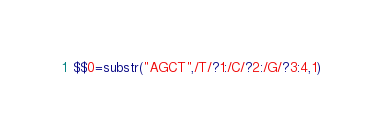Convert code to text. <code><loc_0><loc_0><loc_500><loc_500><_Awk_>$$0=substr("AGCT",/T/?1:/C/?2:/G/?3:4,1)</code> 